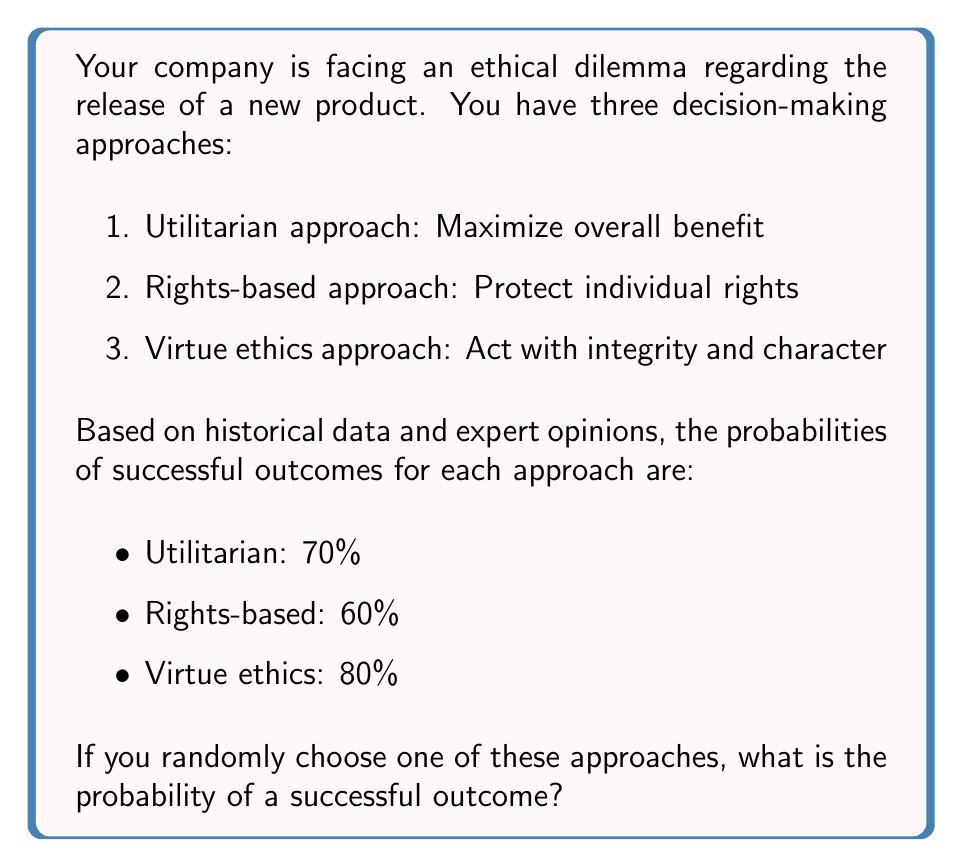Could you help me with this problem? To solve this problem, we need to use the concept of total probability. Since we are randomly choosing one of the three approaches, each approach has an equal probability of being selected, which is $\frac{1}{3}$.

Let's define the events:
- A: Successful outcome
- U: Utilitarian approach
- R: Rights-based approach
- V: Virtue ethics approach

We can calculate the probability of a successful outcome using the formula:

$$P(A) = P(A|U) \cdot P(U) + P(A|R) \cdot P(R) + P(A|V) \cdot P(V)$$

Where:
- $P(A|U)$ is the probability of success given the Utilitarian approach (0.70)
- $P(A|R)$ is the probability of success given the Rights-based approach (0.60)
- $P(A|V)$ is the probability of success given the Virtue ethics approach (0.80)
- $P(U)$, $P(R)$, and $P(V)$ are each $\frac{1}{3}$

Substituting the values:

$$P(A) = 0.70 \cdot \frac{1}{3} + 0.60 \cdot \frac{1}{3} + 0.80 \cdot \frac{1}{3}$$

$$P(A) = \frac{0.70 + 0.60 + 0.80}{3}$$

$$P(A) = \frac{2.10}{3} = 0.70$$

Therefore, the probability of a successful outcome when randomly choosing one of these approaches is 0.70 or 70%.
Answer: 0.70 or 70% 